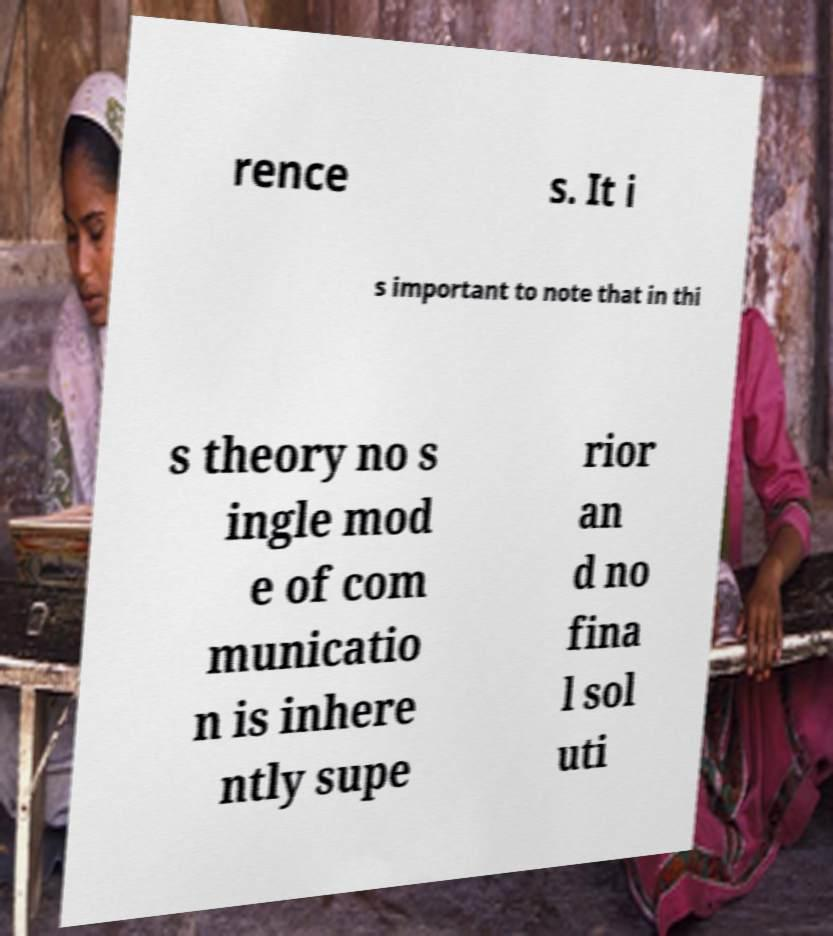What messages or text are displayed in this image? I need them in a readable, typed format. rence s. It i s important to note that in thi s theory no s ingle mod e of com municatio n is inhere ntly supe rior an d no fina l sol uti 